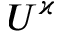<formula> <loc_0><loc_0><loc_500><loc_500>U ^ { \varkappa }</formula> 